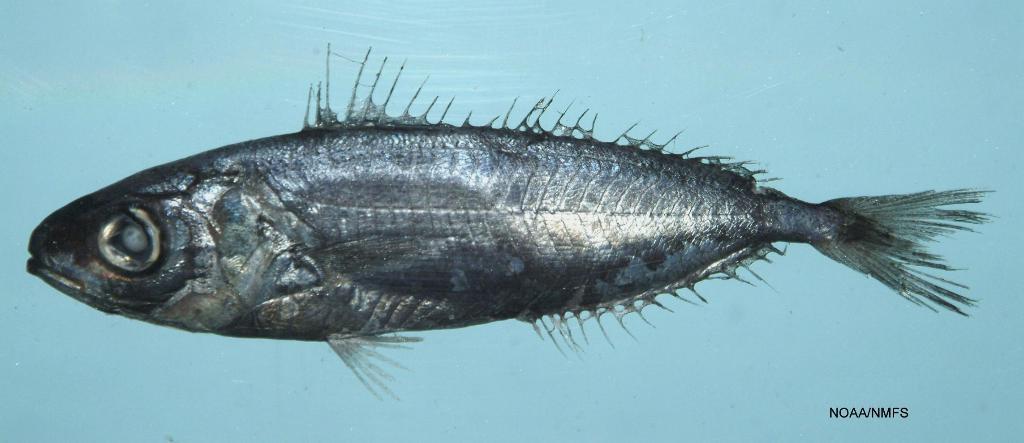Can you describe this image briefly? In this image we can see a fish. The background of the image is blue. In the bottom right we can see some text. 